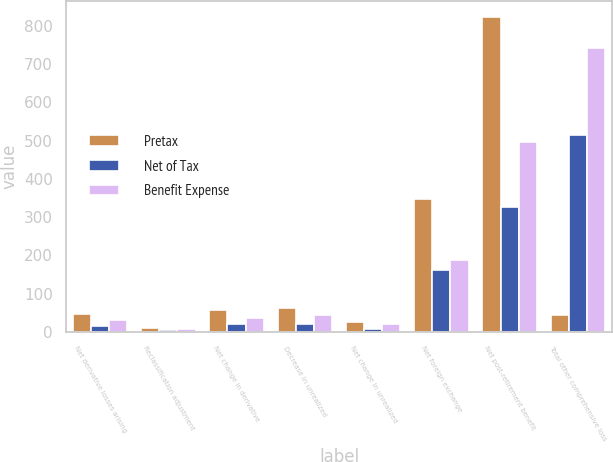Convert chart. <chart><loc_0><loc_0><loc_500><loc_500><stacked_bar_chart><ecel><fcel>Net derivative losses arising<fcel>Reclassification adjustment<fcel>Net change in derivative<fcel>Decrease in unrealized<fcel>Net change in unrealized<fcel>Net foreign exchange<fcel>Net post-retirement benefit<fcel>Total other comprehensive loss<nl><fcel>Pretax<fcel>46<fcel>11<fcel>57<fcel>63<fcel>27<fcel>348<fcel>823<fcel>43<nl><fcel>Net of Tax<fcel>16<fcel>4<fcel>20<fcel>20<fcel>7<fcel>161<fcel>326<fcel>514<nl><fcel>Benefit Expense<fcel>30<fcel>7<fcel>37<fcel>43<fcel>20<fcel>187<fcel>497<fcel>741<nl></chart> 